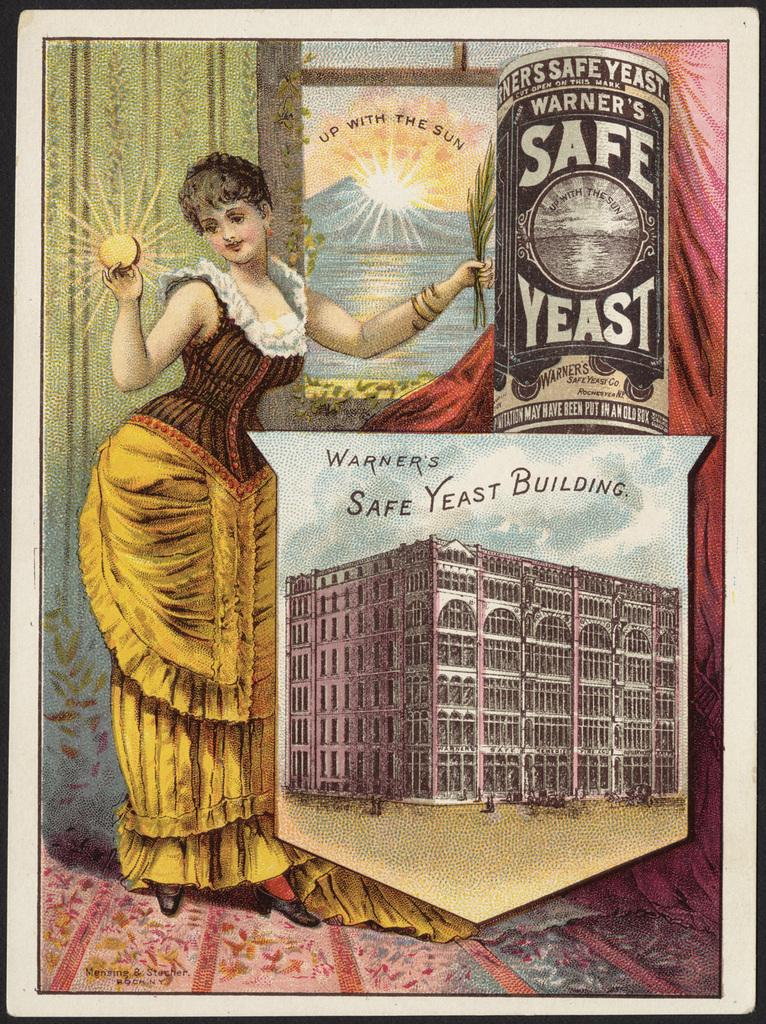<image>
Summarize the visual content of the image. A vintage advertisment for Safe Yeast includes a woman with a corseted waist. 